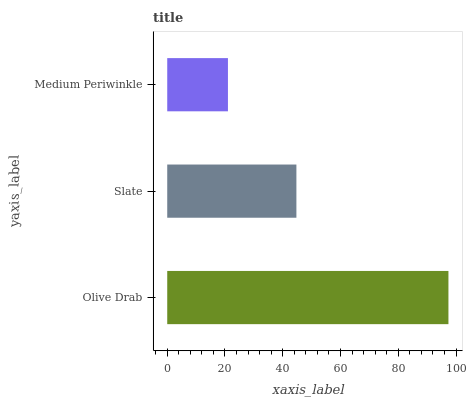Is Medium Periwinkle the minimum?
Answer yes or no. Yes. Is Olive Drab the maximum?
Answer yes or no. Yes. Is Slate the minimum?
Answer yes or no. No. Is Slate the maximum?
Answer yes or no. No. Is Olive Drab greater than Slate?
Answer yes or no. Yes. Is Slate less than Olive Drab?
Answer yes or no. Yes. Is Slate greater than Olive Drab?
Answer yes or no. No. Is Olive Drab less than Slate?
Answer yes or no. No. Is Slate the high median?
Answer yes or no. Yes. Is Slate the low median?
Answer yes or no. Yes. Is Olive Drab the high median?
Answer yes or no. No. Is Medium Periwinkle the low median?
Answer yes or no. No. 